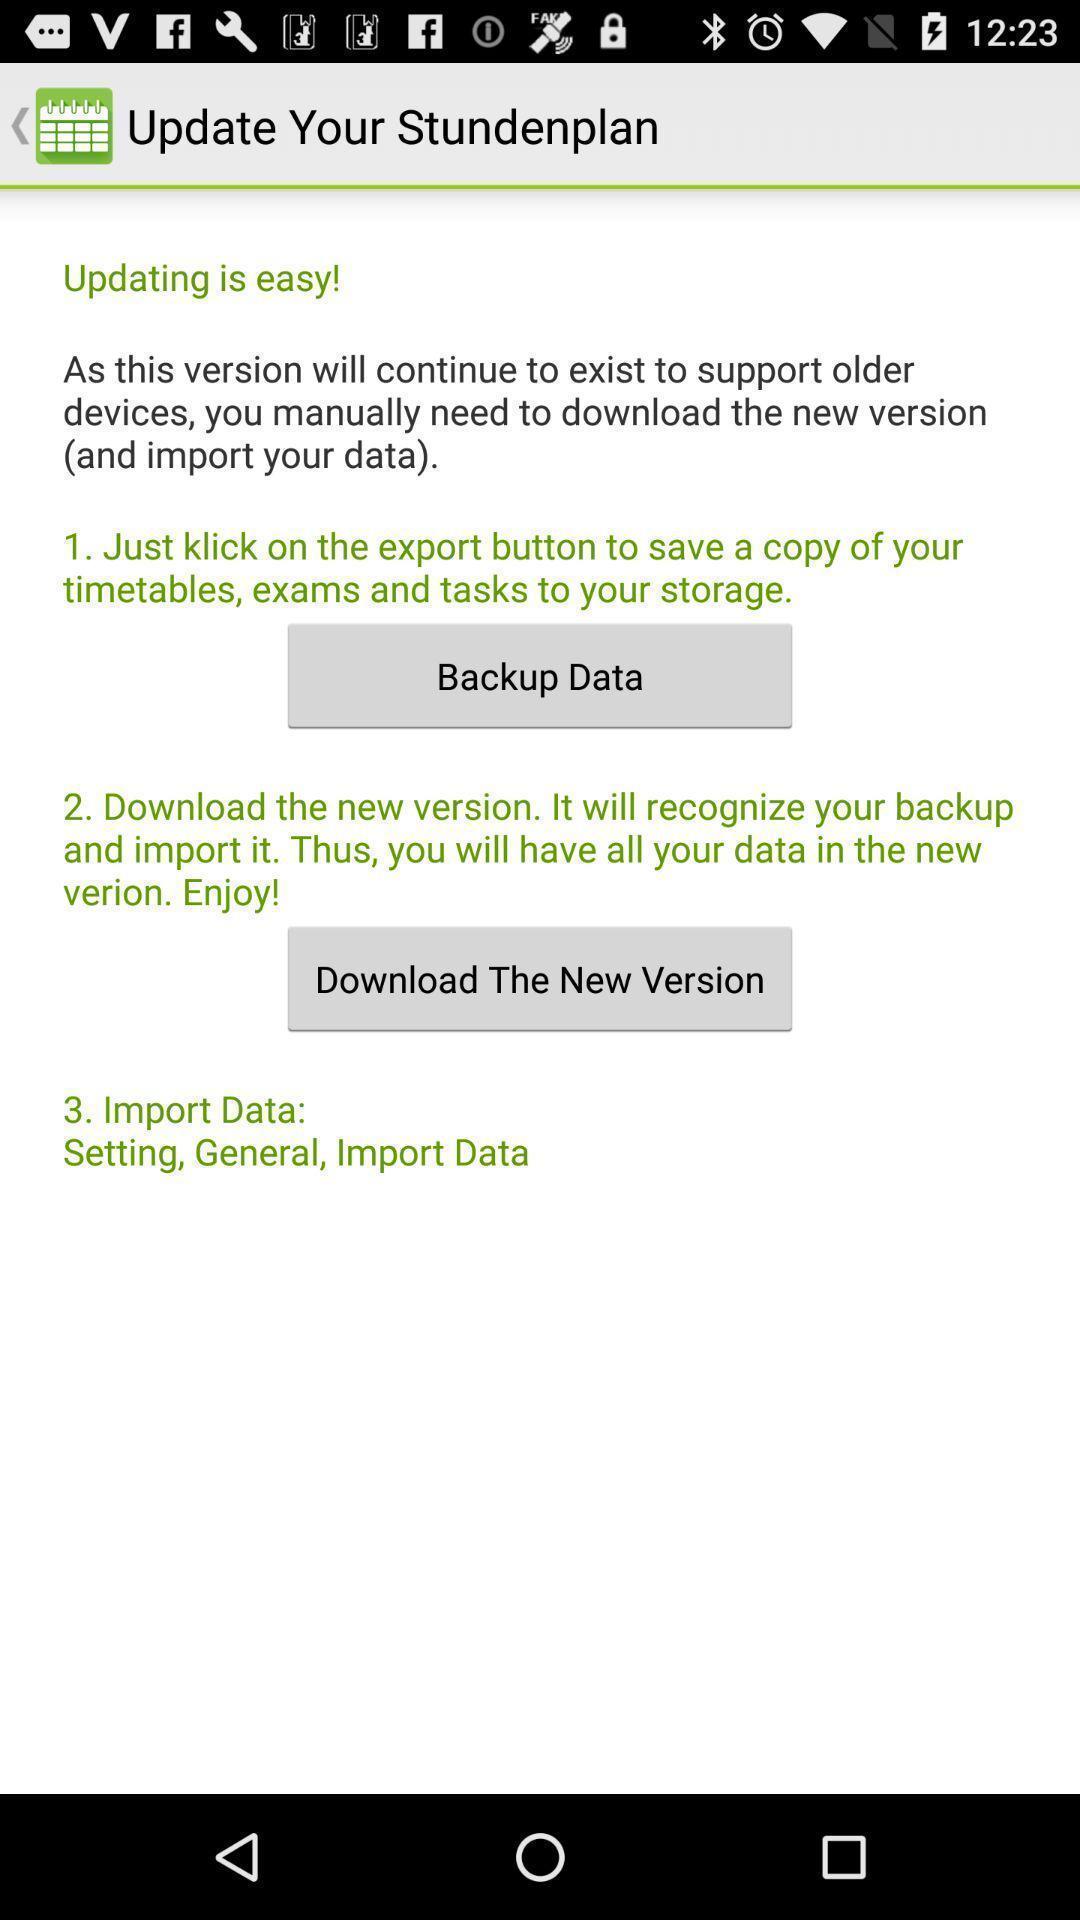Provide a detailed account of this screenshot. Version update information showing in this page. 